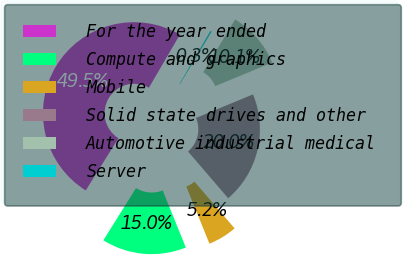Convert chart to OTSL. <chart><loc_0><loc_0><loc_500><loc_500><pie_chart><fcel>For the year ended<fcel>Compute and graphics<fcel>Mobile<fcel>Solid state drives and other<fcel>Automotive industrial medical<fcel>Server<nl><fcel>49.51%<fcel>15.02%<fcel>5.17%<fcel>19.95%<fcel>10.1%<fcel>0.25%<nl></chart> 